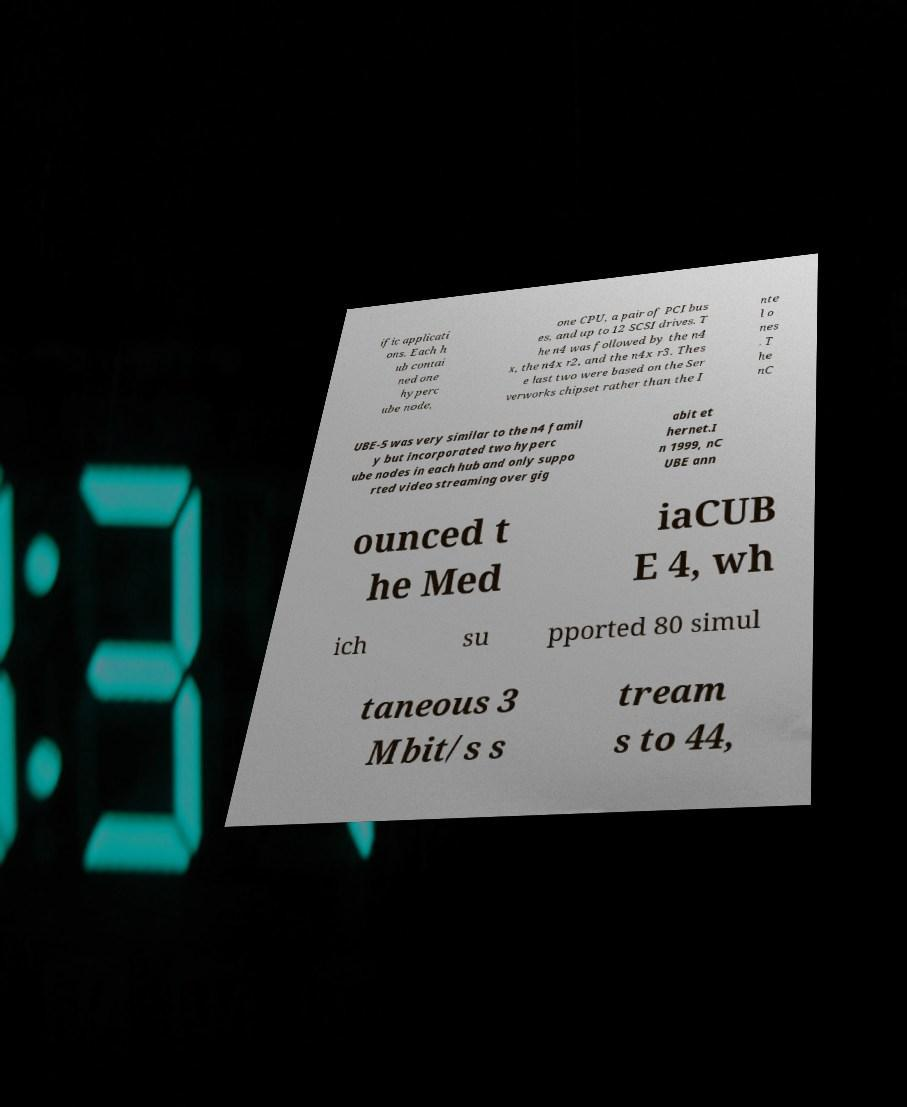Please identify and transcribe the text found in this image. ific applicati ons. Each h ub contai ned one hyperc ube node, one CPU, a pair of PCI bus es, and up to 12 SCSI drives. T he n4 was followed by the n4 x, the n4x r2, and the n4x r3. Thes e last two were based on the Ser verworks chipset rather than the I nte l o nes . T he nC UBE-5 was very similar to the n4 famil y but incorporated two hyperc ube nodes in each hub and only suppo rted video streaming over gig abit et hernet.I n 1999, nC UBE ann ounced t he Med iaCUB E 4, wh ich su pported 80 simul taneous 3 Mbit/s s tream s to 44, 